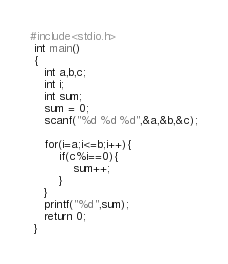<code> <loc_0><loc_0><loc_500><loc_500><_C_>#include<stdio.h>
 int main()
 {
    int a,b,c;
    int i;
    int sum;
    sum = 0;
    scanf("%d %d %d",&a,&b,&c);

    for(i=a;i<=b;i++){
        if(c%i==0){
            sum++;
        }
    }
    printf("%d",sum);
    return 0;
 }
</code> 